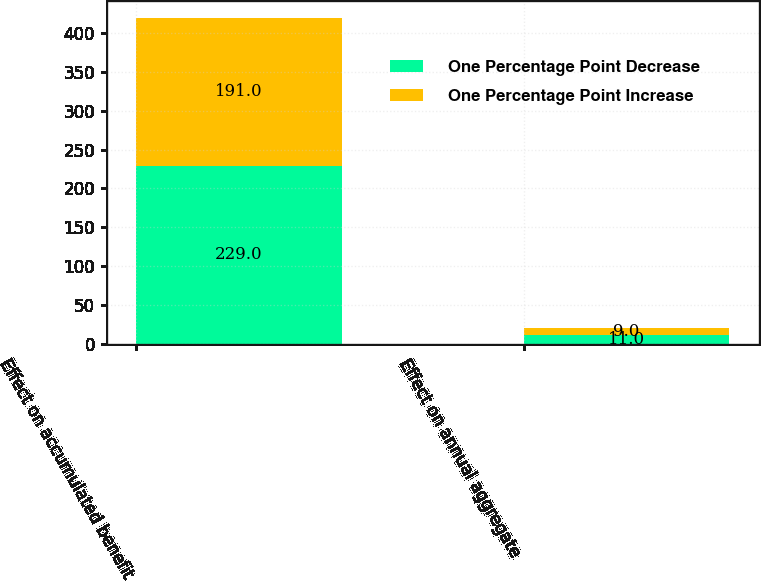Convert chart to OTSL. <chart><loc_0><loc_0><loc_500><loc_500><stacked_bar_chart><ecel><fcel>Effect on accumulated benefit<fcel>Effect on annual aggregate<nl><fcel>One Percentage Point Decrease<fcel>229<fcel>11<nl><fcel>One Percentage Point Increase<fcel>191<fcel>9<nl></chart> 